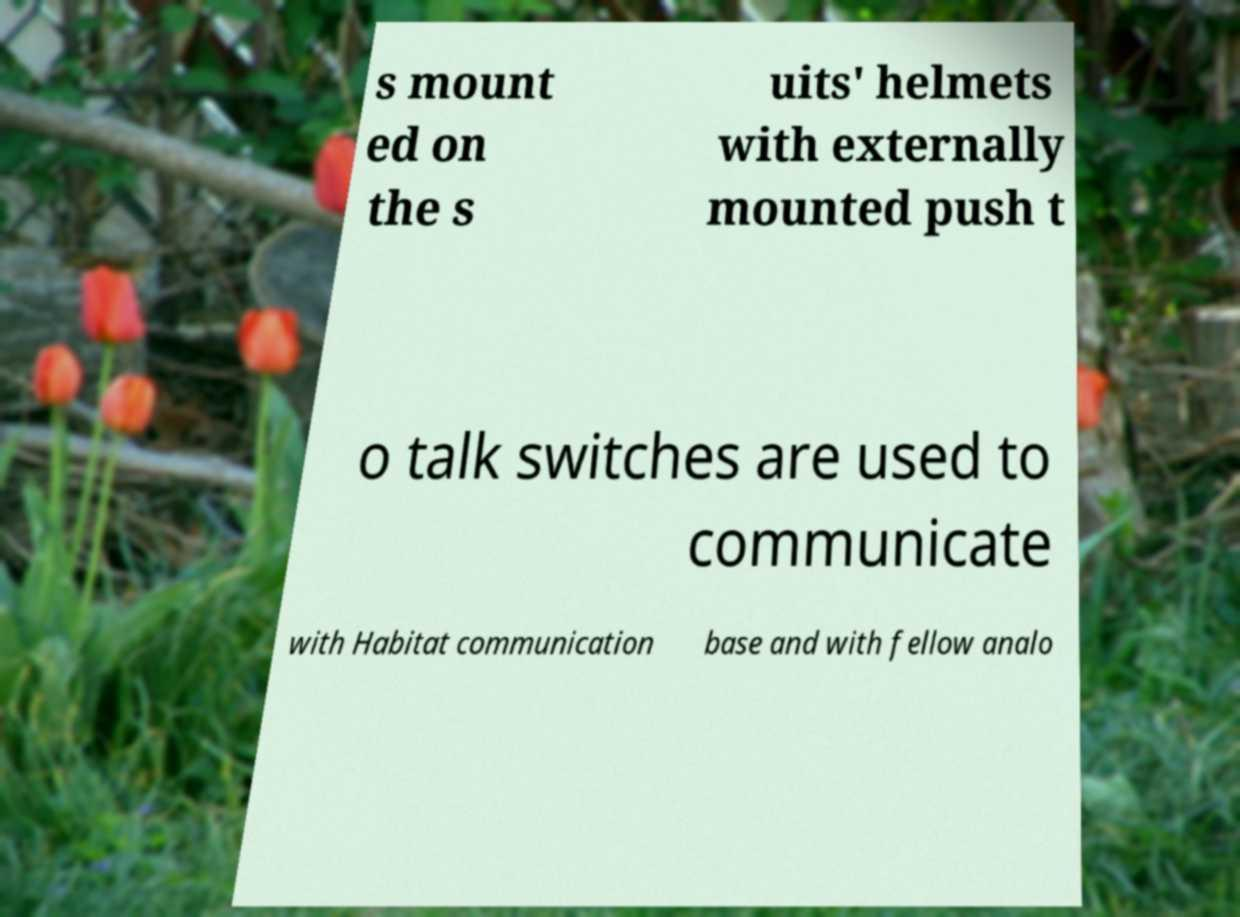There's text embedded in this image that I need extracted. Can you transcribe it verbatim? s mount ed on the s uits' helmets with externally mounted push t o talk switches are used to communicate with Habitat communication base and with fellow analo 